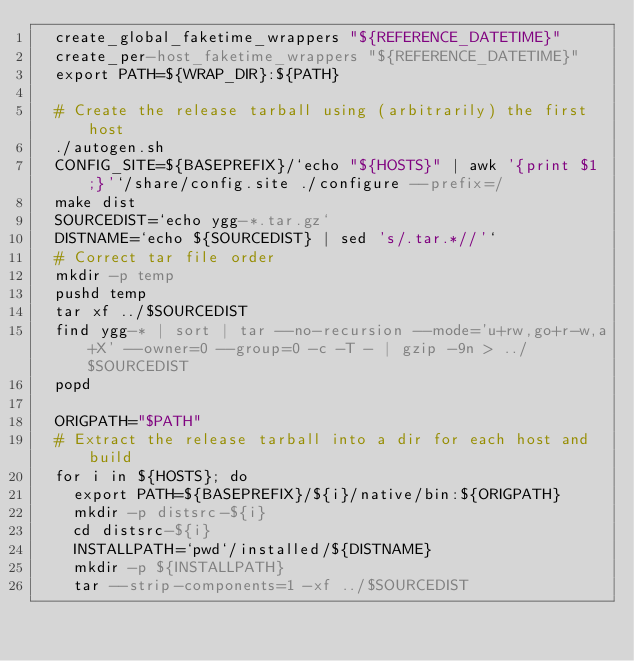Convert code to text. <code><loc_0><loc_0><loc_500><loc_500><_YAML_>  create_global_faketime_wrappers "${REFERENCE_DATETIME}"
  create_per-host_faketime_wrappers "${REFERENCE_DATETIME}"
  export PATH=${WRAP_DIR}:${PATH}

  # Create the release tarball using (arbitrarily) the first host
  ./autogen.sh
  CONFIG_SITE=${BASEPREFIX}/`echo "${HOSTS}" | awk '{print $1;}'`/share/config.site ./configure --prefix=/
  make dist
  SOURCEDIST=`echo ygg-*.tar.gz`
  DISTNAME=`echo ${SOURCEDIST} | sed 's/.tar.*//'`
  # Correct tar file order
  mkdir -p temp
  pushd temp
  tar xf ../$SOURCEDIST
  find ygg-* | sort | tar --no-recursion --mode='u+rw,go+r-w,a+X' --owner=0 --group=0 -c -T - | gzip -9n > ../$SOURCEDIST
  popd

  ORIGPATH="$PATH"
  # Extract the release tarball into a dir for each host and build
  for i in ${HOSTS}; do
    export PATH=${BASEPREFIX}/${i}/native/bin:${ORIGPATH}
    mkdir -p distsrc-${i}
    cd distsrc-${i}
    INSTALLPATH=`pwd`/installed/${DISTNAME}
    mkdir -p ${INSTALLPATH}
    tar --strip-components=1 -xf ../$SOURCEDIST
</code> 